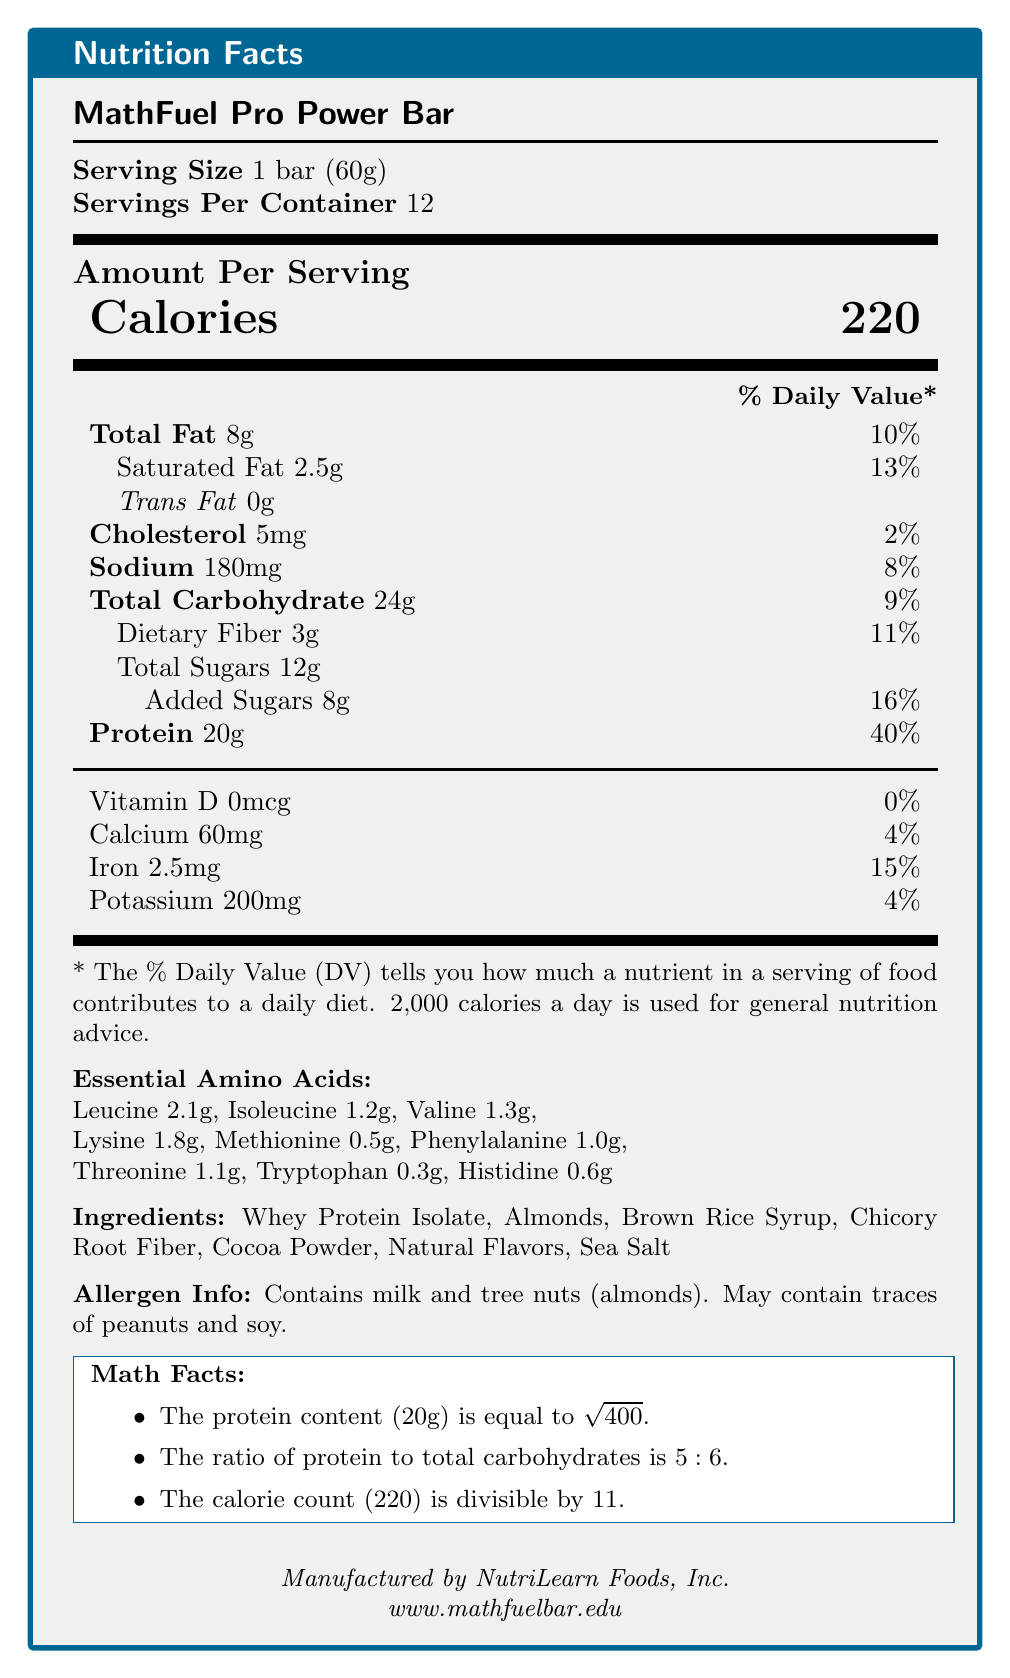what is the product name? The product name is stated at the beginning of the document as "MathFuel Pro Power Bar."
Answer: MathFuel Pro Power Bar what is the serving size? The serving size is listed under "Serving Size" as "1 bar (60g)."
Answer: 1 bar (60g) how many calories are in one serving? The number of calories per serving is prominently displayed as "Calories 220."
Answer: 220 how many grams of protein are in one serving? The protein content per serving is listed as "Protein 20g" under the nutrition facts.
Answer: 20g what percentage of the daily value of protein does one bar provide? Under "Protein," it states "20g," which is 40% of the daily value.
Answer: 40% which ingredient is listed first? The ingredients are listed in order of prevalence, with "Whey Protein Isolate" being the first ingredient.
Answer: Whey Protein Isolate list two allergens mentioned in the allergen info. The allergen information specifies "Contains milk and tree nuts (almonds)."
Answer: Milk and tree nuts (almonds) does the product contain any trans fat? The document specifies "Trans Fat 0g," indicating there is no trans fat.
Answer: No how much calcium is in one serving? The calcium content per serving is listed as "Calcium 60mg."
Answer: 60mg what are the essential amino acids included in the product? All the essential amino acids are listed under "Essential Amino Acids."
Answer: Leucine, Isoleucine, Valine, Lysine, Methionine, Phenylalanine, Threonine, Tryptophan, Histidine what is the ratio of protein to total carbohydrates in the product? A. 1:1 B. 4:5 C. 5:6 D. 6:7 The math facts section mentions "The ratio of protein to total carbohydrates is 5:6."
Answer: C. 5:6 which company manufactures the MathFuel Pro Power Bar? A. NutriCorp B. Math-Eat Inc. C. NutriLearn Foods, Inc. The document states the manufacturer as "NutriLearn Foods, Inc."
Answer: C. NutriLearn Foods, Inc. is the calorie count divisible by 11? The math facts section mentions "The calorie count (220) is divisible by 11."
Answer: Yes how many servings are in one container? The servings per container are listed as "12."
Answer: 12 what is the square root of the protein content in grams? The math facts state "The protein content (20g) is equal to the square root of 400," which is 20.
Answer: 20 is there any information about the price of the product? The document does not provide any information about the price.
Answer: Not enough information describe the main idea of the document. The document provides a comprehensive breakdown of the nutritional content and other related information for the MathFuel Pro Power Bar, helping consumers understand its nutritional value and allergen information. It also includes fun math-related facts associating the bar's nutritional content with math concepts.
Answer: The document is a detailed nutrition facts label for the MathFuel Pro Power Bar, including information on serving size, calories, macronutrients, essential amino acids, ingredients, allergens, math facts related to nutrition, and manufacturer details. is there more sugar or dietary fiber in one serving? The document lists "Total Sugars 12g" and "Dietary Fiber 3g," indicating there is more sugar than dietary fiber in one serving.
Answer: Sugar which essential amino acid is present in the highest quantity? The document lists Leucine content as "2.1g," which is higher than any other essential amino acid mentioned.
Answer: Leucine 